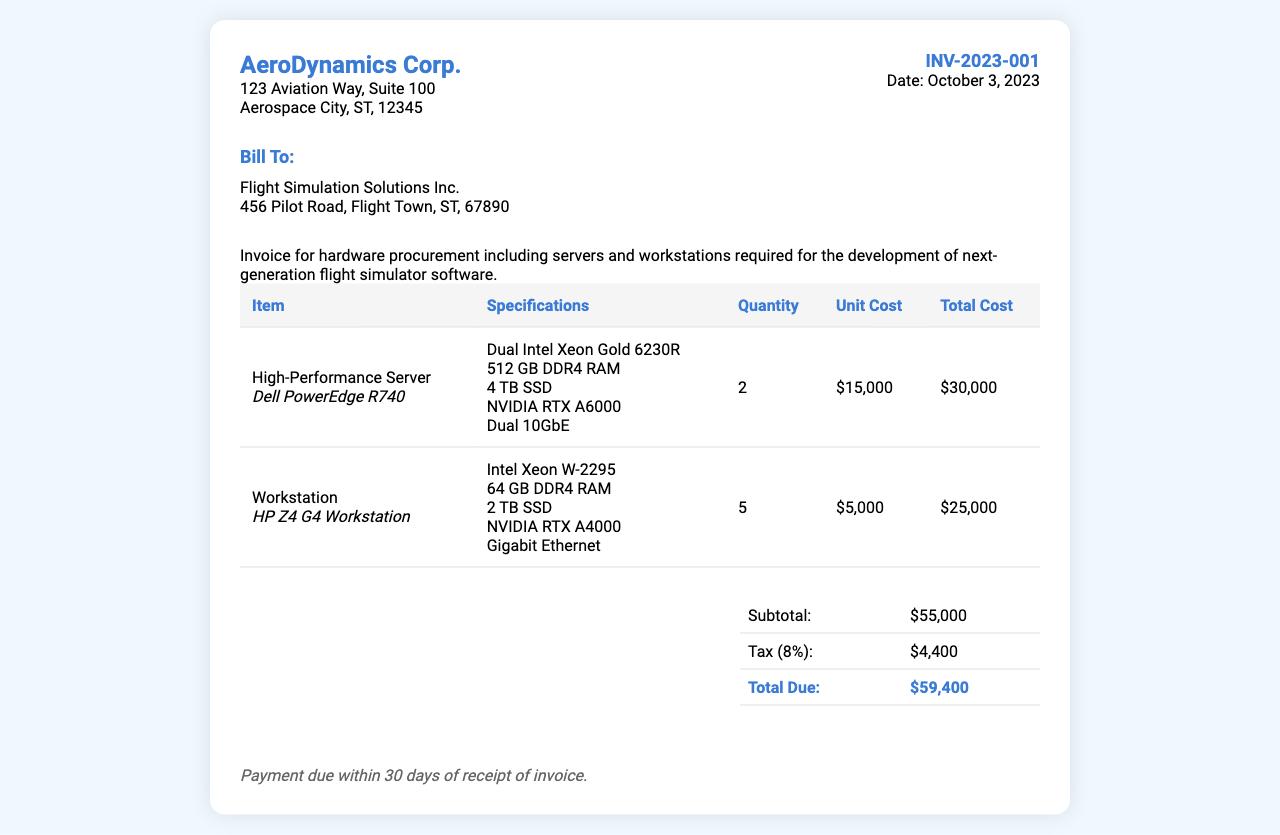What is the invoice number? The invoice number is explicitly stated in the document under invoice details.
Answer: INV-2023-001 What is the date of the invoice? The date of the invoice is prominently displayed in the invoice details section.
Answer: October 3, 2023 Who is the billing recipient? The billing recipient is specified in the 'Bill To' section of the document.
Answer: Flight Simulation Solutions Inc How many high-performance servers are included in the invoice? The quantity of high-performance servers is detailed in the itemized table of the document.
Answer: 2 What is the total cost for the workstations? The total cost for workstations can be calculated by multiplying the unit cost by the quantity in the invoice.
Answer: $25,000 What is the subtotal amount before tax? The subtotal is shown clearly in the summary table in the document.
Answer: $55,000 What is the tax percentage applied in the invoice? The tax percentage is specified in the summary section, which also includes the calculation.
Answer: 8% What is the total amount due? The total amount due is presented in the summary table as the final amount owed.
Answer: $59,400 How many total items are billed in this invoice? The total number of items refers to the distinct entries in the itemized list within the invoice.
Answer: 2 